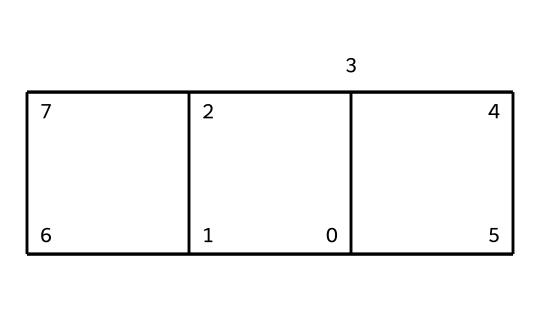What is the number of carbon atoms in cubane? The structure of cubane, represented by the provided SMILES, indicates each vertex of the cube corresponds to a carbon atom. Since cubane has eight vertices, it contains eight carbon atoms.
Answer: eight What is the major structural shape of cubane? Analyzing the SMILES representation reveals that the atoms are arranged in a three-dimensional cube formation, which characterizes cubane.
Answer: cube How many hydrogen atoms are in cubane? Each carbon atom in cubane is connected to two hydrogen atoms due to its tetrahedral bonding structure, leading to a total of sixteen hydrogen atoms (8 carbons x 2 hydrogens).
Answer: sixteen What type of chemical is cubane classified as? Given its fully saturated carbon structure and absence of functional groups, cubane is classified as a saturated hydrocarbon.
Answer: saturated hydrocarbon What is unique about the bond angles in cubane compared to typical hydrocarbons? In the case of cubane, the bond angles around each carbon are 90 degrees due to the square planar arrangement of its bonds, differing from the typical tetrahedral bond angles of 109.5 degrees in alkanes.
Answer: 90 degrees How does cubane's structure impact its stability? The highly strained bond angles (90 degrees) and the overall strain of the cube shape lead to cubane being a less stable compound compared to more traditional alkanes, which feature less torsional strain.
Answer: less stable What kind of molecular strain is associated with cubane? Cubane experiences significant angle strain and torsional strain because its bond angles deviate from the ideal tetrahedral angle of 109.5 degrees, increasing instability.
Answer: angle strain and torsional strain 